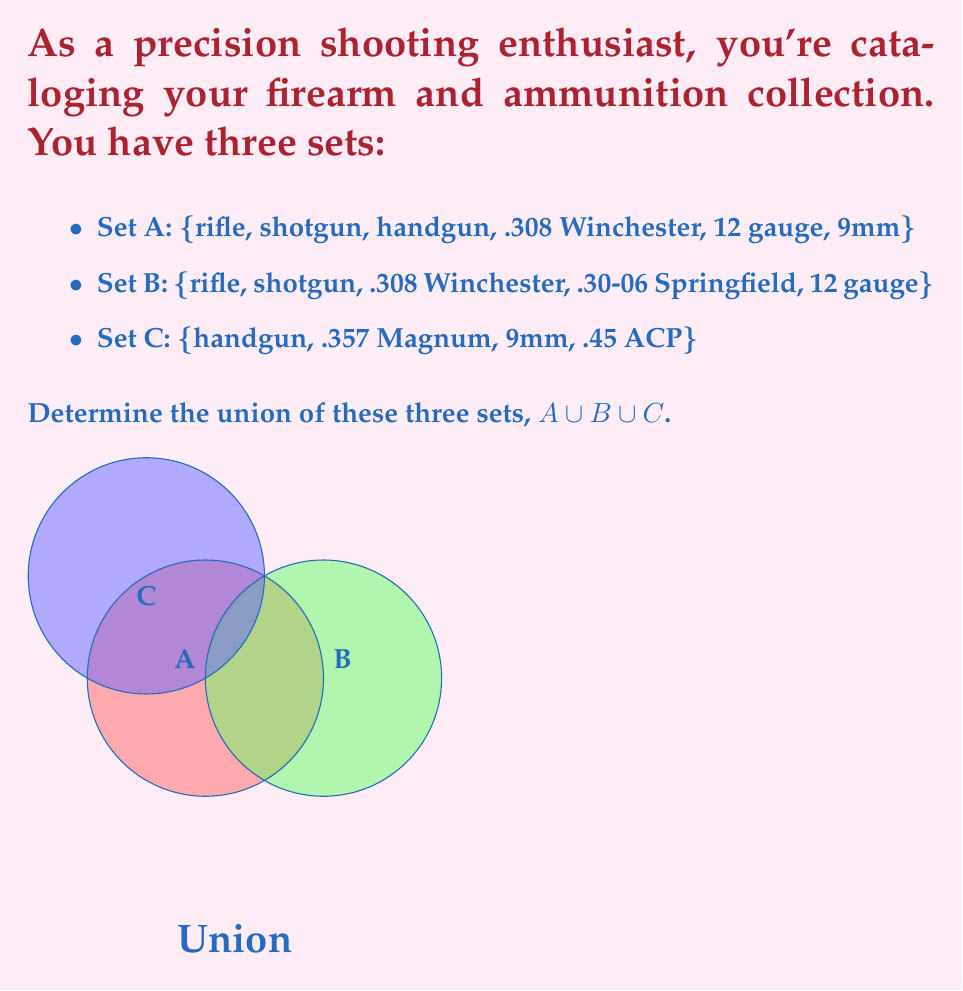Could you help me with this problem? To find the union of sets A, B, and C, we need to list all unique elements that appear in at least one of the sets. Let's break this down step-by-step:

1) First, let's list all elements from set A:
   {rifle, shotgun, handgun, .308 Winchester, 12 gauge, 9mm}

2) Now, let's add any new elements from set B that aren't already in our list:
   {rifle, shotgun, handgun, .308 Winchester, 12 gauge, 9mm, .30-06 Springfield}

3) Finally, let's add any new elements from set C that aren't already in our list:
   {rifle, shotgun, handgun, .308 Winchester, 12 gauge, 9mm, .30-06 Springfield, .357 Magnum, .45 ACP}

4) This final list represents $A \cup B \cup C$, as it contains all unique elements from all three sets.

Mathematically, we can express this as:

$$A \cup B \cup C = \{x | x \in A \text{ or } x \in B \text{ or } x \in C\}$$

Where $x$ represents each element in the resulting set.
Answer: {rifle, shotgun, handgun, .308 Winchester, 12 gauge, 9mm, .30-06 Springfield, .357 Magnum, .45 ACP} 